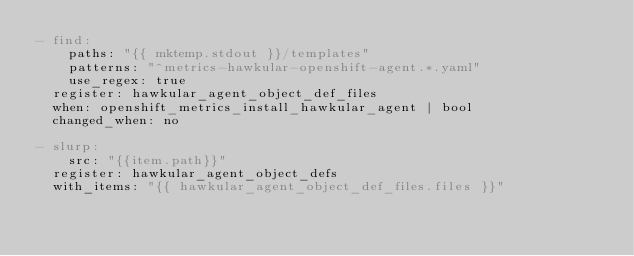<code> <loc_0><loc_0><loc_500><loc_500><_YAML_>- find:
    paths: "{{ mktemp.stdout }}/templates"
    patterns: "^metrics-hawkular-openshift-agent.*.yaml"
    use_regex: true
  register: hawkular_agent_object_def_files
  when: openshift_metrics_install_hawkular_agent | bool
  changed_when: no

- slurp:
    src: "{{item.path}}"
  register: hawkular_agent_object_defs
  with_items: "{{ hawkular_agent_object_def_files.files }}"</code> 